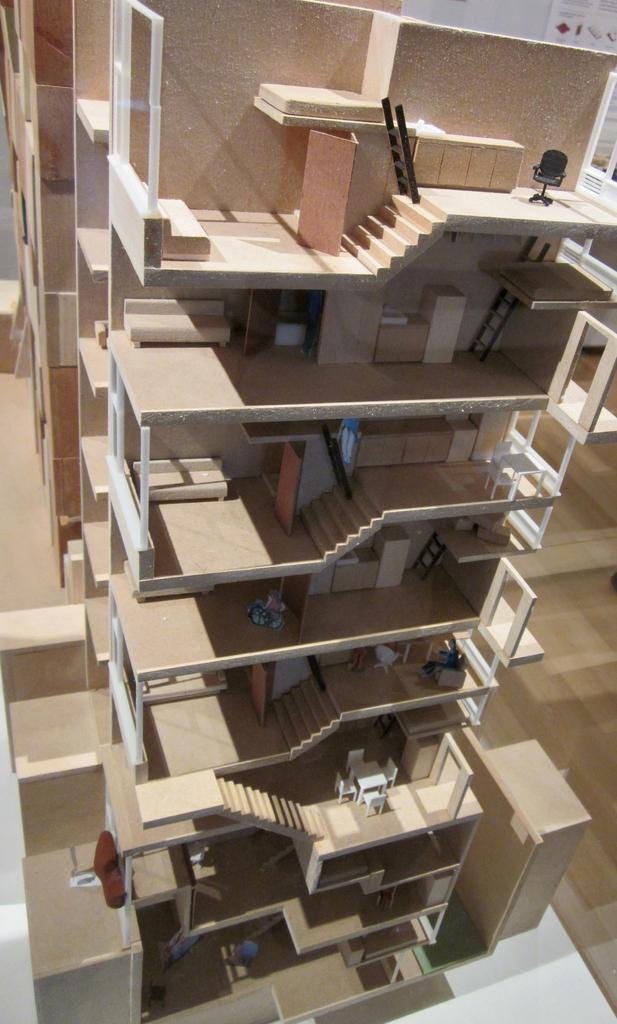What type of architectural feature can be seen in the image? There are staircases in the image. What other elements are visible in the image? There are windows and a wall visible in the image. What can be inferred about the location of the image? The image appears to be taken in a building. What is the opinion of the ear in the image? There is no ear present in the image, so it is not possible to determine its opinion. 